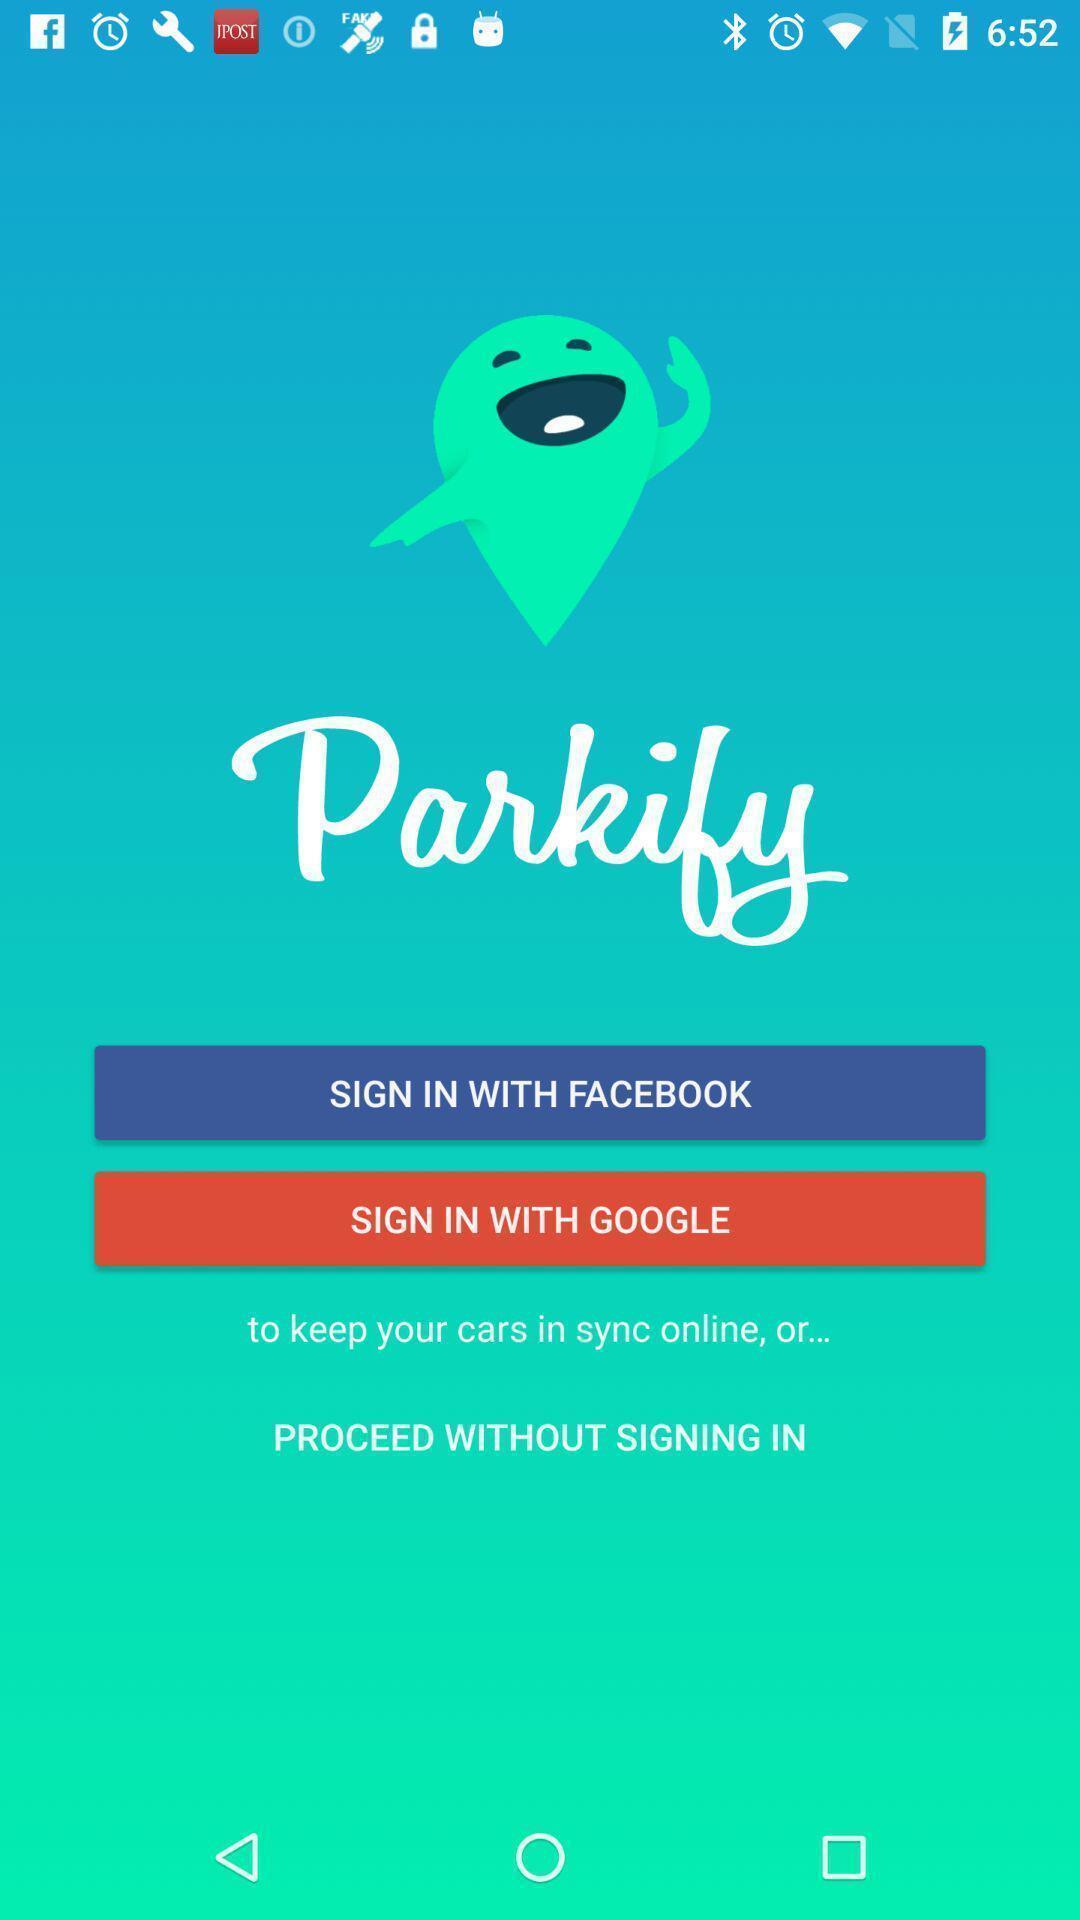Summarize the information in this screenshot. Welcome page for a vehicle locator app. 